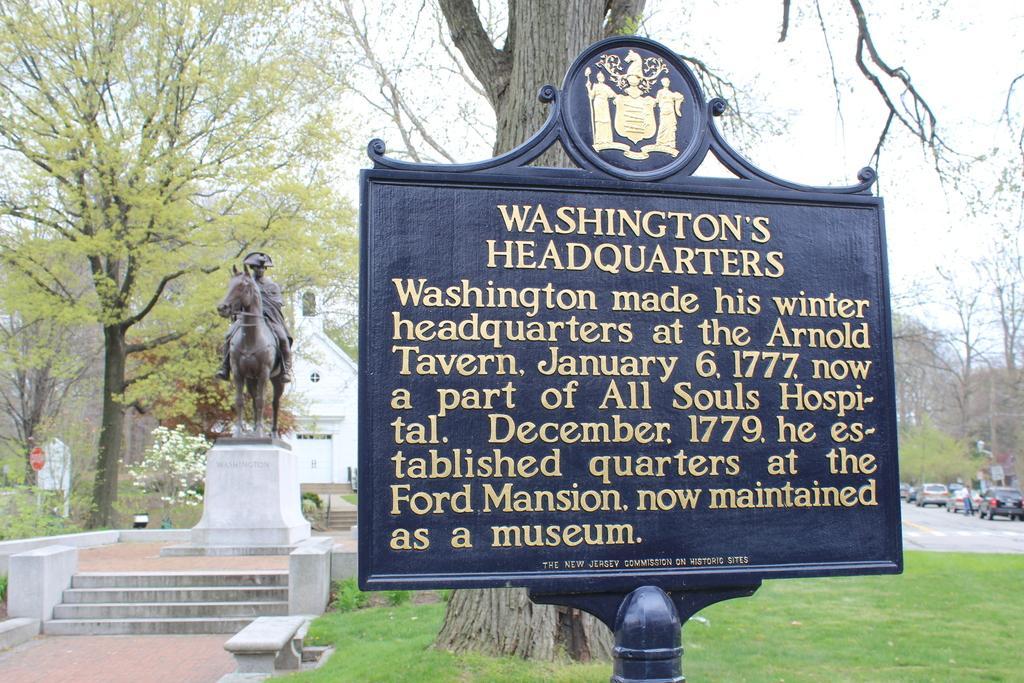Describe this image in one or two sentences. In this image we can see a board with some text and images, also we can see a statue, there are some trees, vehicles, plants, flowers, grass, bench, staircases, boards and a house, in the background we can see the sky. 